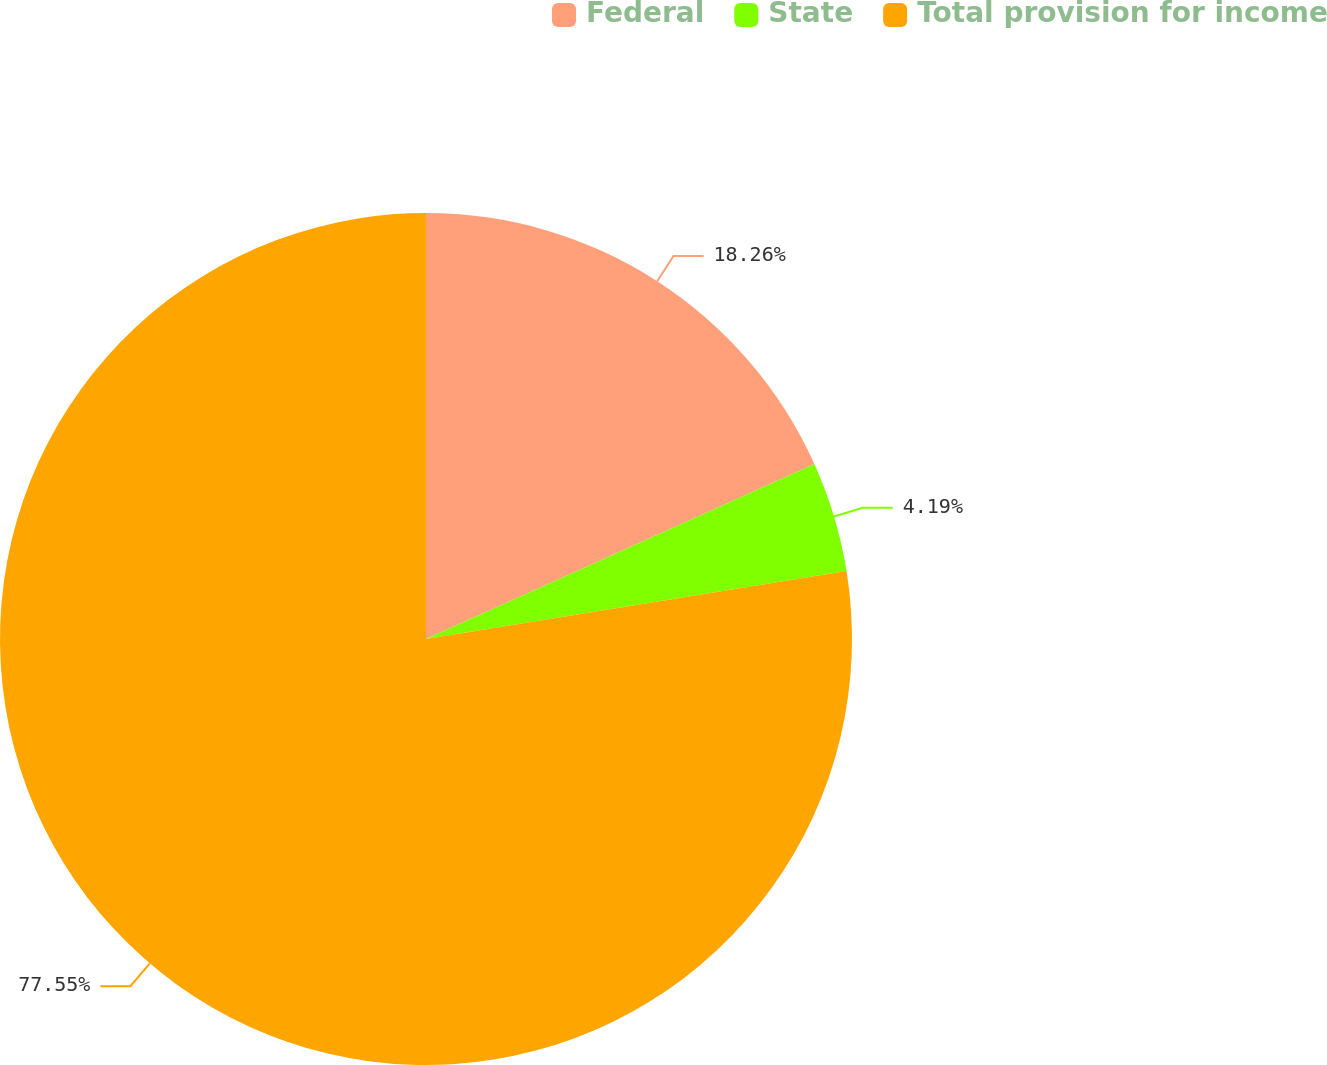Convert chart to OTSL. <chart><loc_0><loc_0><loc_500><loc_500><pie_chart><fcel>Federal<fcel>State<fcel>Total provision for income<nl><fcel>18.26%<fcel>4.19%<fcel>77.54%<nl></chart> 